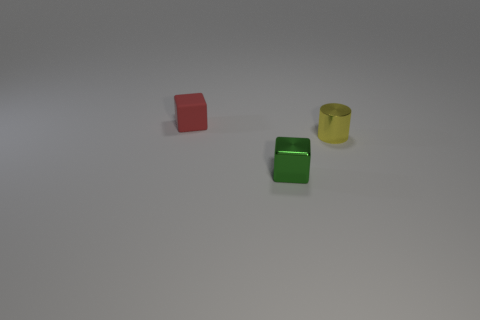There is a shiny object that is behind the green metal cube; what is its color?
Offer a very short reply. Yellow. What size is the shiny cube?
Ensure brevity in your answer.  Small. Is the size of the rubber object the same as the thing that is in front of the small cylinder?
Keep it short and to the point. Yes. There is a tiny object that is in front of the small metal object on the right side of the tiny cube that is right of the matte object; what color is it?
Ensure brevity in your answer.  Green. Are the tiny yellow thing behind the green block and the tiny green cube made of the same material?
Provide a short and direct response. Yes. What number of other things are made of the same material as the tiny yellow object?
Give a very brief answer. 1. What material is the red block that is the same size as the yellow shiny object?
Your answer should be very brief. Rubber. There is a thing behind the yellow thing; is its shape the same as the tiny metallic object behind the green metal block?
Provide a short and direct response. No. What is the shape of the yellow thing that is the same size as the rubber block?
Your answer should be compact. Cylinder. Is the material of the tiny thing to the left of the tiny metallic block the same as the tiny block in front of the metallic cylinder?
Offer a terse response. No. 